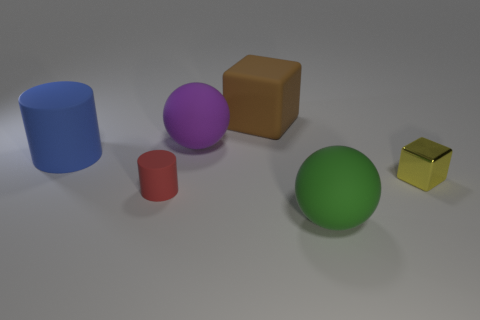Is the number of large things that are behind the shiny thing the same as the number of tiny red rubber spheres? no 